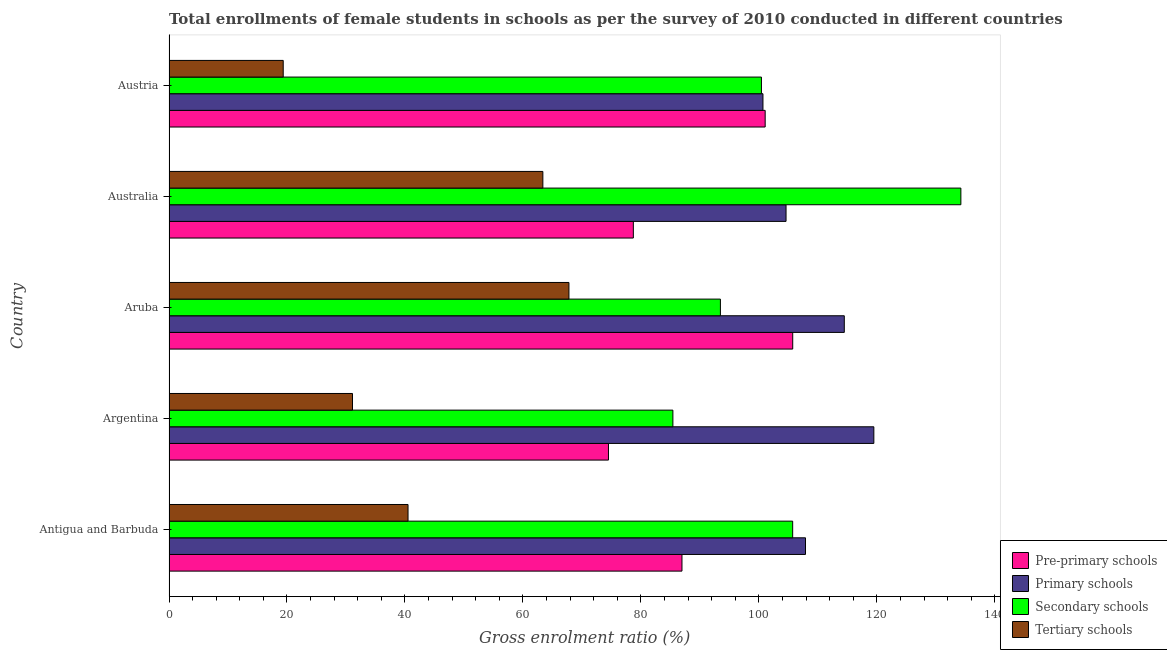How many different coloured bars are there?
Provide a succinct answer. 4. Are the number of bars per tick equal to the number of legend labels?
Your answer should be very brief. Yes. How many bars are there on the 2nd tick from the bottom?
Offer a very short reply. 4. What is the gross enrolment ratio(female) in primary schools in Aruba?
Your answer should be very brief. 114.48. Across all countries, what is the maximum gross enrolment ratio(female) in secondary schools?
Give a very brief answer. 134.24. Across all countries, what is the minimum gross enrolment ratio(female) in pre-primary schools?
Your answer should be compact. 74.5. In which country was the gross enrolment ratio(female) in pre-primary schools maximum?
Provide a short and direct response. Aruba. In which country was the gross enrolment ratio(female) in secondary schools minimum?
Provide a succinct answer. Argentina. What is the total gross enrolment ratio(female) in pre-primary schools in the graph?
Your answer should be very brief. 446.97. What is the difference between the gross enrolment ratio(female) in primary schools in Antigua and Barbuda and that in Aruba?
Offer a very short reply. -6.58. What is the difference between the gross enrolment ratio(female) in tertiary schools in Australia and the gross enrolment ratio(female) in primary schools in Aruba?
Provide a succinct answer. -51.1. What is the average gross enrolment ratio(female) in pre-primary schools per country?
Provide a succinct answer. 89.39. What is the difference between the gross enrolment ratio(female) in pre-primary schools and gross enrolment ratio(female) in tertiary schools in Antigua and Barbuda?
Your answer should be compact. 46.44. In how many countries, is the gross enrolment ratio(female) in secondary schools greater than 44 %?
Ensure brevity in your answer.  5. What is the ratio of the gross enrolment ratio(female) in pre-primary schools in Australia to that in Austria?
Give a very brief answer. 0.78. Is the gross enrolment ratio(female) in secondary schools in Argentina less than that in Austria?
Offer a terse response. Yes. Is the difference between the gross enrolment ratio(female) in secondary schools in Argentina and Australia greater than the difference between the gross enrolment ratio(female) in tertiary schools in Argentina and Australia?
Ensure brevity in your answer.  No. What is the difference between the highest and the second highest gross enrolment ratio(female) in pre-primary schools?
Your response must be concise. 4.67. What is the difference between the highest and the lowest gross enrolment ratio(female) in pre-primary schools?
Your answer should be compact. 31.23. Is it the case that in every country, the sum of the gross enrolment ratio(female) in primary schools and gross enrolment ratio(female) in secondary schools is greater than the sum of gross enrolment ratio(female) in pre-primary schools and gross enrolment ratio(female) in tertiary schools?
Provide a short and direct response. Yes. What does the 2nd bar from the top in Aruba represents?
Give a very brief answer. Secondary schools. What does the 1st bar from the bottom in Austria represents?
Ensure brevity in your answer.  Pre-primary schools. Is it the case that in every country, the sum of the gross enrolment ratio(female) in pre-primary schools and gross enrolment ratio(female) in primary schools is greater than the gross enrolment ratio(female) in secondary schools?
Your answer should be very brief. Yes. Are all the bars in the graph horizontal?
Give a very brief answer. Yes. What is the difference between two consecutive major ticks on the X-axis?
Give a very brief answer. 20. Are the values on the major ticks of X-axis written in scientific E-notation?
Make the answer very short. No. Does the graph contain any zero values?
Your answer should be very brief. No. Where does the legend appear in the graph?
Provide a short and direct response. Bottom right. What is the title of the graph?
Offer a very short reply. Total enrollments of female students in schools as per the survey of 2010 conducted in different countries. What is the label or title of the X-axis?
Keep it short and to the point. Gross enrolment ratio (%). What is the Gross enrolment ratio (%) of Pre-primary schools in Antigua and Barbuda?
Offer a very short reply. 86.96. What is the Gross enrolment ratio (%) in Primary schools in Antigua and Barbuda?
Offer a very short reply. 107.9. What is the Gross enrolment ratio (%) in Secondary schools in Antigua and Barbuda?
Provide a succinct answer. 105.73. What is the Gross enrolment ratio (%) in Tertiary schools in Antigua and Barbuda?
Ensure brevity in your answer.  40.52. What is the Gross enrolment ratio (%) in Pre-primary schools in Argentina?
Keep it short and to the point. 74.5. What is the Gross enrolment ratio (%) in Primary schools in Argentina?
Provide a succinct answer. 119.49. What is the Gross enrolment ratio (%) of Secondary schools in Argentina?
Your response must be concise. 85.42. What is the Gross enrolment ratio (%) of Tertiary schools in Argentina?
Your answer should be compact. 31.11. What is the Gross enrolment ratio (%) in Pre-primary schools in Aruba?
Your response must be concise. 105.73. What is the Gross enrolment ratio (%) of Primary schools in Aruba?
Ensure brevity in your answer.  114.48. What is the Gross enrolment ratio (%) of Secondary schools in Aruba?
Offer a terse response. 93.48. What is the Gross enrolment ratio (%) of Tertiary schools in Aruba?
Your answer should be compact. 67.8. What is the Gross enrolment ratio (%) in Pre-primary schools in Australia?
Offer a terse response. 78.72. What is the Gross enrolment ratio (%) of Primary schools in Australia?
Make the answer very short. 104.6. What is the Gross enrolment ratio (%) in Secondary schools in Australia?
Offer a very short reply. 134.24. What is the Gross enrolment ratio (%) in Tertiary schools in Australia?
Offer a terse response. 63.38. What is the Gross enrolment ratio (%) of Pre-primary schools in Austria?
Provide a succinct answer. 101.06. What is the Gross enrolment ratio (%) in Primary schools in Austria?
Keep it short and to the point. 100.69. What is the Gross enrolment ratio (%) of Secondary schools in Austria?
Make the answer very short. 100.43. What is the Gross enrolment ratio (%) of Tertiary schools in Austria?
Keep it short and to the point. 19.36. Across all countries, what is the maximum Gross enrolment ratio (%) in Pre-primary schools?
Offer a very short reply. 105.73. Across all countries, what is the maximum Gross enrolment ratio (%) of Primary schools?
Keep it short and to the point. 119.49. Across all countries, what is the maximum Gross enrolment ratio (%) in Secondary schools?
Provide a succinct answer. 134.24. Across all countries, what is the maximum Gross enrolment ratio (%) in Tertiary schools?
Your response must be concise. 67.8. Across all countries, what is the minimum Gross enrolment ratio (%) in Pre-primary schools?
Give a very brief answer. 74.5. Across all countries, what is the minimum Gross enrolment ratio (%) of Primary schools?
Your answer should be very brief. 100.69. Across all countries, what is the minimum Gross enrolment ratio (%) of Secondary schools?
Give a very brief answer. 85.42. Across all countries, what is the minimum Gross enrolment ratio (%) of Tertiary schools?
Provide a succinct answer. 19.36. What is the total Gross enrolment ratio (%) in Pre-primary schools in the graph?
Your response must be concise. 446.97. What is the total Gross enrolment ratio (%) in Primary schools in the graph?
Your answer should be very brief. 547.15. What is the total Gross enrolment ratio (%) in Secondary schools in the graph?
Offer a very short reply. 519.29. What is the total Gross enrolment ratio (%) in Tertiary schools in the graph?
Make the answer very short. 222.17. What is the difference between the Gross enrolment ratio (%) in Pre-primary schools in Antigua and Barbuda and that in Argentina?
Your answer should be very brief. 12.46. What is the difference between the Gross enrolment ratio (%) in Primary schools in Antigua and Barbuda and that in Argentina?
Ensure brevity in your answer.  -11.59. What is the difference between the Gross enrolment ratio (%) in Secondary schools in Antigua and Barbuda and that in Argentina?
Your answer should be compact. 20.31. What is the difference between the Gross enrolment ratio (%) of Tertiary schools in Antigua and Barbuda and that in Argentina?
Offer a very short reply. 9.41. What is the difference between the Gross enrolment ratio (%) in Pre-primary schools in Antigua and Barbuda and that in Aruba?
Your answer should be compact. -18.77. What is the difference between the Gross enrolment ratio (%) in Primary schools in Antigua and Barbuda and that in Aruba?
Make the answer very short. -6.58. What is the difference between the Gross enrolment ratio (%) of Secondary schools in Antigua and Barbuda and that in Aruba?
Give a very brief answer. 12.25. What is the difference between the Gross enrolment ratio (%) of Tertiary schools in Antigua and Barbuda and that in Aruba?
Offer a terse response. -27.28. What is the difference between the Gross enrolment ratio (%) in Pre-primary schools in Antigua and Barbuda and that in Australia?
Your answer should be very brief. 8.24. What is the difference between the Gross enrolment ratio (%) of Primary schools in Antigua and Barbuda and that in Australia?
Make the answer very short. 3.3. What is the difference between the Gross enrolment ratio (%) in Secondary schools in Antigua and Barbuda and that in Australia?
Your response must be concise. -28.52. What is the difference between the Gross enrolment ratio (%) of Tertiary schools in Antigua and Barbuda and that in Australia?
Provide a succinct answer. -22.86. What is the difference between the Gross enrolment ratio (%) in Pre-primary schools in Antigua and Barbuda and that in Austria?
Make the answer very short. -14.1. What is the difference between the Gross enrolment ratio (%) in Primary schools in Antigua and Barbuda and that in Austria?
Ensure brevity in your answer.  7.21. What is the difference between the Gross enrolment ratio (%) of Secondary schools in Antigua and Barbuda and that in Austria?
Your answer should be compact. 5.29. What is the difference between the Gross enrolment ratio (%) in Tertiary schools in Antigua and Barbuda and that in Austria?
Ensure brevity in your answer.  21.16. What is the difference between the Gross enrolment ratio (%) in Pre-primary schools in Argentina and that in Aruba?
Give a very brief answer. -31.23. What is the difference between the Gross enrolment ratio (%) in Primary schools in Argentina and that in Aruba?
Provide a short and direct response. 5.01. What is the difference between the Gross enrolment ratio (%) of Secondary schools in Argentina and that in Aruba?
Your answer should be compact. -8.06. What is the difference between the Gross enrolment ratio (%) in Tertiary schools in Argentina and that in Aruba?
Offer a terse response. -36.69. What is the difference between the Gross enrolment ratio (%) of Pre-primary schools in Argentina and that in Australia?
Your response must be concise. -4.22. What is the difference between the Gross enrolment ratio (%) in Primary schools in Argentina and that in Australia?
Make the answer very short. 14.88. What is the difference between the Gross enrolment ratio (%) in Secondary schools in Argentina and that in Australia?
Provide a short and direct response. -48.82. What is the difference between the Gross enrolment ratio (%) in Tertiary schools in Argentina and that in Australia?
Your response must be concise. -32.27. What is the difference between the Gross enrolment ratio (%) of Pre-primary schools in Argentina and that in Austria?
Provide a succinct answer. -26.56. What is the difference between the Gross enrolment ratio (%) of Primary schools in Argentina and that in Austria?
Offer a very short reply. 18.8. What is the difference between the Gross enrolment ratio (%) of Secondary schools in Argentina and that in Austria?
Offer a terse response. -15.01. What is the difference between the Gross enrolment ratio (%) in Tertiary schools in Argentina and that in Austria?
Offer a terse response. 11.75. What is the difference between the Gross enrolment ratio (%) of Pre-primary schools in Aruba and that in Australia?
Offer a terse response. 27.02. What is the difference between the Gross enrolment ratio (%) of Primary schools in Aruba and that in Australia?
Provide a short and direct response. 9.88. What is the difference between the Gross enrolment ratio (%) in Secondary schools in Aruba and that in Australia?
Give a very brief answer. -40.76. What is the difference between the Gross enrolment ratio (%) of Tertiary schools in Aruba and that in Australia?
Offer a terse response. 4.42. What is the difference between the Gross enrolment ratio (%) in Pre-primary schools in Aruba and that in Austria?
Ensure brevity in your answer.  4.67. What is the difference between the Gross enrolment ratio (%) of Primary schools in Aruba and that in Austria?
Offer a terse response. 13.79. What is the difference between the Gross enrolment ratio (%) in Secondary schools in Aruba and that in Austria?
Provide a short and direct response. -6.96. What is the difference between the Gross enrolment ratio (%) in Tertiary schools in Aruba and that in Austria?
Give a very brief answer. 48.43. What is the difference between the Gross enrolment ratio (%) of Pre-primary schools in Australia and that in Austria?
Make the answer very short. -22.35. What is the difference between the Gross enrolment ratio (%) in Primary schools in Australia and that in Austria?
Your answer should be very brief. 3.91. What is the difference between the Gross enrolment ratio (%) of Secondary schools in Australia and that in Austria?
Offer a very short reply. 33.81. What is the difference between the Gross enrolment ratio (%) in Tertiary schools in Australia and that in Austria?
Your answer should be compact. 44.02. What is the difference between the Gross enrolment ratio (%) in Pre-primary schools in Antigua and Barbuda and the Gross enrolment ratio (%) in Primary schools in Argentina?
Your answer should be compact. -32.53. What is the difference between the Gross enrolment ratio (%) in Pre-primary schools in Antigua and Barbuda and the Gross enrolment ratio (%) in Secondary schools in Argentina?
Give a very brief answer. 1.54. What is the difference between the Gross enrolment ratio (%) in Pre-primary schools in Antigua and Barbuda and the Gross enrolment ratio (%) in Tertiary schools in Argentina?
Make the answer very short. 55.85. What is the difference between the Gross enrolment ratio (%) of Primary schools in Antigua and Barbuda and the Gross enrolment ratio (%) of Secondary schools in Argentina?
Your response must be concise. 22.48. What is the difference between the Gross enrolment ratio (%) in Primary schools in Antigua and Barbuda and the Gross enrolment ratio (%) in Tertiary schools in Argentina?
Keep it short and to the point. 76.79. What is the difference between the Gross enrolment ratio (%) in Secondary schools in Antigua and Barbuda and the Gross enrolment ratio (%) in Tertiary schools in Argentina?
Your answer should be very brief. 74.62. What is the difference between the Gross enrolment ratio (%) of Pre-primary schools in Antigua and Barbuda and the Gross enrolment ratio (%) of Primary schools in Aruba?
Keep it short and to the point. -27.52. What is the difference between the Gross enrolment ratio (%) in Pre-primary schools in Antigua and Barbuda and the Gross enrolment ratio (%) in Secondary schools in Aruba?
Offer a very short reply. -6.52. What is the difference between the Gross enrolment ratio (%) of Pre-primary schools in Antigua and Barbuda and the Gross enrolment ratio (%) of Tertiary schools in Aruba?
Provide a short and direct response. 19.16. What is the difference between the Gross enrolment ratio (%) of Primary schools in Antigua and Barbuda and the Gross enrolment ratio (%) of Secondary schools in Aruba?
Your answer should be compact. 14.42. What is the difference between the Gross enrolment ratio (%) of Primary schools in Antigua and Barbuda and the Gross enrolment ratio (%) of Tertiary schools in Aruba?
Provide a short and direct response. 40.1. What is the difference between the Gross enrolment ratio (%) in Secondary schools in Antigua and Barbuda and the Gross enrolment ratio (%) in Tertiary schools in Aruba?
Ensure brevity in your answer.  37.93. What is the difference between the Gross enrolment ratio (%) of Pre-primary schools in Antigua and Barbuda and the Gross enrolment ratio (%) of Primary schools in Australia?
Make the answer very short. -17.64. What is the difference between the Gross enrolment ratio (%) in Pre-primary schools in Antigua and Barbuda and the Gross enrolment ratio (%) in Secondary schools in Australia?
Give a very brief answer. -47.28. What is the difference between the Gross enrolment ratio (%) in Pre-primary schools in Antigua and Barbuda and the Gross enrolment ratio (%) in Tertiary schools in Australia?
Provide a succinct answer. 23.58. What is the difference between the Gross enrolment ratio (%) in Primary schools in Antigua and Barbuda and the Gross enrolment ratio (%) in Secondary schools in Australia?
Make the answer very short. -26.34. What is the difference between the Gross enrolment ratio (%) in Primary schools in Antigua and Barbuda and the Gross enrolment ratio (%) in Tertiary schools in Australia?
Make the answer very short. 44.52. What is the difference between the Gross enrolment ratio (%) of Secondary schools in Antigua and Barbuda and the Gross enrolment ratio (%) of Tertiary schools in Australia?
Make the answer very short. 42.35. What is the difference between the Gross enrolment ratio (%) in Pre-primary schools in Antigua and Barbuda and the Gross enrolment ratio (%) in Primary schools in Austria?
Your answer should be compact. -13.73. What is the difference between the Gross enrolment ratio (%) in Pre-primary schools in Antigua and Barbuda and the Gross enrolment ratio (%) in Secondary schools in Austria?
Make the answer very short. -13.47. What is the difference between the Gross enrolment ratio (%) in Pre-primary schools in Antigua and Barbuda and the Gross enrolment ratio (%) in Tertiary schools in Austria?
Offer a very short reply. 67.6. What is the difference between the Gross enrolment ratio (%) of Primary schools in Antigua and Barbuda and the Gross enrolment ratio (%) of Secondary schools in Austria?
Give a very brief answer. 7.47. What is the difference between the Gross enrolment ratio (%) in Primary schools in Antigua and Barbuda and the Gross enrolment ratio (%) in Tertiary schools in Austria?
Your answer should be very brief. 88.54. What is the difference between the Gross enrolment ratio (%) in Secondary schools in Antigua and Barbuda and the Gross enrolment ratio (%) in Tertiary schools in Austria?
Ensure brevity in your answer.  86.36. What is the difference between the Gross enrolment ratio (%) in Pre-primary schools in Argentina and the Gross enrolment ratio (%) in Primary schools in Aruba?
Provide a succinct answer. -39.98. What is the difference between the Gross enrolment ratio (%) in Pre-primary schools in Argentina and the Gross enrolment ratio (%) in Secondary schools in Aruba?
Offer a terse response. -18.98. What is the difference between the Gross enrolment ratio (%) of Pre-primary schools in Argentina and the Gross enrolment ratio (%) of Tertiary schools in Aruba?
Provide a short and direct response. 6.7. What is the difference between the Gross enrolment ratio (%) in Primary schools in Argentina and the Gross enrolment ratio (%) in Secondary schools in Aruba?
Provide a short and direct response. 26.01. What is the difference between the Gross enrolment ratio (%) of Primary schools in Argentina and the Gross enrolment ratio (%) of Tertiary schools in Aruba?
Your answer should be compact. 51.69. What is the difference between the Gross enrolment ratio (%) of Secondary schools in Argentina and the Gross enrolment ratio (%) of Tertiary schools in Aruba?
Your answer should be very brief. 17.62. What is the difference between the Gross enrolment ratio (%) of Pre-primary schools in Argentina and the Gross enrolment ratio (%) of Primary schools in Australia?
Your response must be concise. -30.1. What is the difference between the Gross enrolment ratio (%) in Pre-primary schools in Argentina and the Gross enrolment ratio (%) in Secondary schools in Australia?
Your response must be concise. -59.74. What is the difference between the Gross enrolment ratio (%) in Pre-primary schools in Argentina and the Gross enrolment ratio (%) in Tertiary schools in Australia?
Your answer should be very brief. 11.12. What is the difference between the Gross enrolment ratio (%) of Primary schools in Argentina and the Gross enrolment ratio (%) of Secondary schools in Australia?
Make the answer very short. -14.76. What is the difference between the Gross enrolment ratio (%) in Primary schools in Argentina and the Gross enrolment ratio (%) in Tertiary schools in Australia?
Your answer should be very brief. 56.11. What is the difference between the Gross enrolment ratio (%) of Secondary schools in Argentina and the Gross enrolment ratio (%) of Tertiary schools in Australia?
Offer a very short reply. 22.04. What is the difference between the Gross enrolment ratio (%) of Pre-primary schools in Argentina and the Gross enrolment ratio (%) of Primary schools in Austria?
Provide a succinct answer. -26.19. What is the difference between the Gross enrolment ratio (%) in Pre-primary schools in Argentina and the Gross enrolment ratio (%) in Secondary schools in Austria?
Keep it short and to the point. -25.93. What is the difference between the Gross enrolment ratio (%) of Pre-primary schools in Argentina and the Gross enrolment ratio (%) of Tertiary schools in Austria?
Your response must be concise. 55.14. What is the difference between the Gross enrolment ratio (%) in Primary schools in Argentina and the Gross enrolment ratio (%) in Secondary schools in Austria?
Your answer should be compact. 19.05. What is the difference between the Gross enrolment ratio (%) in Primary schools in Argentina and the Gross enrolment ratio (%) in Tertiary schools in Austria?
Ensure brevity in your answer.  100.12. What is the difference between the Gross enrolment ratio (%) of Secondary schools in Argentina and the Gross enrolment ratio (%) of Tertiary schools in Austria?
Ensure brevity in your answer.  66.06. What is the difference between the Gross enrolment ratio (%) of Pre-primary schools in Aruba and the Gross enrolment ratio (%) of Primary schools in Australia?
Give a very brief answer. 1.13. What is the difference between the Gross enrolment ratio (%) of Pre-primary schools in Aruba and the Gross enrolment ratio (%) of Secondary schools in Australia?
Your response must be concise. -28.51. What is the difference between the Gross enrolment ratio (%) of Pre-primary schools in Aruba and the Gross enrolment ratio (%) of Tertiary schools in Australia?
Your answer should be compact. 42.36. What is the difference between the Gross enrolment ratio (%) in Primary schools in Aruba and the Gross enrolment ratio (%) in Secondary schools in Australia?
Offer a very short reply. -19.76. What is the difference between the Gross enrolment ratio (%) of Primary schools in Aruba and the Gross enrolment ratio (%) of Tertiary schools in Australia?
Offer a terse response. 51.1. What is the difference between the Gross enrolment ratio (%) of Secondary schools in Aruba and the Gross enrolment ratio (%) of Tertiary schools in Australia?
Give a very brief answer. 30.1. What is the difference between the Gross enrolment ratio (%) in Pre-primary schools in Aruba and the Gross enrolment ratio (%) in Primary schools in Austria?
Provide a short and direct response. 5.05. What is the difference between the Gross enrolment ratio (%) in Pre-primary schools in Aruba and the Gross enrolment ratio (%) in Secondary schools in Austria?
Your response must be concise. 5.3. What is the difference between the Gross enrolment ratio (%) in Pre-primary schools in Aruba and the Gross enrolment ratio (%) in Tertiary schools in Austria?
Keep it short and to the point. 86.37. What is the difference between the Gross enrolment ratio (%) of Primary schools in Aruba and the Gross enrolment ratio (%) of Secondary schools in Austria?
Your answer should be compact. 14.05. What is the difference between the Gross enrolment ratio (%) of Primary schools in Aruba and the Gross enrolment ratio (%) of Tertiary schools in Austria?
Ensure brevity in your answer.  95.11. What is the difference between the Gross enrolment ratio (%) in Secondary schools in Aruba and the Gross enrolment ratio (%) in Tertiary schools in Austria?
Your answer should be very brief. 74.11. What is the difference between the Gross enrolment ratio (%) in Pre-primary schools in Australia and the Gross enrolment ratio (%) in Primary schools in Austria?
Ensure brevity in your answer.  -21.97. What is the difference between the Gross enrolment ratio (%) of Pre-primary schools in Australia and the Gross enrolment ratio (%) of Secondary schools in Austria?
Keep it short and to the point. -21.72. What is the difference between the Gross enrolment ratio (%) of Pre-primary schools in Australia and the Gross enrolment ratio (%) of Tertiary schools in Austria?
Ensure brevity in your answer.  59.35. What is the difference between the Gross enrolment ratio (%) of Primary schools in Australia and the Gross enrolment ratio (%) of Secondary schools in Austria?
Give a very brief answer. 4.17. What is the difference between the Gross enrolment ratio (%) of Primary schools in Australia and the Gross enrolment ratio (%) of Tertiary schools in Austria?
Give a very brief answer. 85.24. What is the difference between the Gross enrolment ratio (%) in Secondary schools in Australia and the Gross enrolment ratio (%) in Tertiary schools in Austria?
Provide a short and direct response. 114.88. What is the average Gross enrolment ratio (%) in Pre-primary schools per country?
Keep it short and to the point. 89.39. What is the average Gross enrolment ratio (%) of Primary schools per country?
Keep it short and to the point. 109.43. What is the average Gross enrolment ratio (%) in Secondary schools per country?
Offer a very short reply. 103.86. What is the average Gross enrolment ratio (%) of Tertiary schools per country?
Provide a succinct answer. 44.43. What is the difference between the Gross enrolment ratio (%) of Pre-primary schools and Gross enrolment ratio (%) of Primary schools in Antigua and Barbuda?
Offer a very short reply. -20.94. What is the difference between the Gross enrolment ratio (%) in Pre-primary schools and Gross enrolment ratio (%) in Secondary schools in Antigua and Barbuda?
Your response must be concise. -18.77. What is the difference between the Gross enrolment ratio (%) of Pre-primary schools and Gross enrolment ratio (%) of Tertiary schools in Antigua and Barbuda?
Your answer should be compact. 46.44. What is the difference between the Gross enrolment ratio (%) in Primary schools and Gross enrolment ratio (%) in Secondary schools in Antigua and Barbuda?
Provide a succinct answer. 2.18. What is the difference between the Gross enrolment ratio (%) in Primary schools and Gross enrolment ratio (%) in Tertiary schools in Antigua and Barbuda?
Make the answer very short. 67.38. What is the difference between the Gross enrolment ratio (%) of Secondary schools and Gross enrolment ratio (%) of Tertiary schools in Antigua and Barbuda?
Make the answer very short. 65.2. What is the difference between the Gross enrolment ratio (%) in Pre-primary schools and Gross enrolment ratio (%) in Primary schools in Argentina?
Your answer should be compact. -44.99. What is the difference between the Gross enrolment ratio (%) in Pre-primary schools and Gross enrolment ratio (%) in Secondary schools in Argentina?
Make the answer very short. -10.92. What is the difference between the Gross enrolment ratio (%) in Pre-primary schools and Gross enrolment ratio (%) in Tertiary schools in Argentina?
Offer a terse response. 43.39. What is the difference between the Gross enrolment ratio (%) in Primary schools and Gross enrolment ratio (%) in Secondary schools in Argentina?
Your response must be concise. 34.07. What is the difference between the Gross enrolment ratio (%) of Primary schools and Gross enrolment ratio (%) of Tertiary schools in Argentina?
Ensure brevity in your answer.  88.38. What is the difference between the Gross enrolment ratio (%) in Secondary schools and Gross enrolment ratio (%) in Tertiary schools in Argentina?
Offer a terse response. 54.31. What is the difference between the Gross enrolment ratio (%) in Pre-primary schools and Gross enrolment ratio (%) in Primary schools in Aruba?
Keep it short and to the point. -8.74. What is the difference between the Gross enrolment ratio (%) in Pre-primary schools and Gross enrolment ratio (%) in Secondary schools in Aruba?
Your response must be concise. 12.26. What is the difference between the Gross enrolment ratio (%) of Pre-primary schools and Gross enrolment ratio (%) of Tertiary schools in Aruba?
Provide a succinct answer. 37.94. What is the difference between the Gross enrolment ratio (%) of Primary schools and Gross enrolment ratio (%) of Secondary schools in Aruba?
Give a very brief answer. 21. What is the difference between the Gross enrolment ratio (%) in Primary schools and Gross enrolment ratio (%) in Tertiary schools in Aruba?
Give a very brief answer. 46.68. What is the difference between the Gross enrolment ratio (%) of Secondary schools and Gross enrolment ratio (%) of Tertiary schools in Aruba?
Give a very brief answer. 25.68. What is the difference between the Gross enrolment ratio (%) in Pre-primary schools and Gross enrolment ratio (%) in Primary schools in Australia?
Provide a succinct answer. -25.89. What is the difference between the Gross enrolment ratio (%) of Pre-primary schools and Gross enrolment ratio (%) of Secondary schools in Australia?
Make the answer very short. -55.53. What is the difference between the Gross enrolment ratio (%) in Pre-primary schools and Gross enrolment ratio (%) in Tertiary schools in Australia?
Your answer should be compact. 15.34. What is the difference between the Gross enrolment ratio (%) of Primary schools and Gross enrolment ratio (%) of Secondary schools in Australia?
Provide a short and direct response. -29.64. What is the difference between the Gross enrolment ratio (%) of Primary schools and Gross enrolment ratio (%) of Tertiary schools in Australia?
Make the answer very short. 41.22. What is the difference between the Gross enrolment ratio (%) in Secondary schools and Gross enrolment ratio (%) in Tertiary schools in Australia?
Ensure brevity in your answer.  70.86. What is the difference between the Gross enrolment ratio (%) in Pre-primary schools and Gross enrolment ratio (%) in Primary schools in Austria?
Keep it short and to the point. 0.38. What is the difference between the Gross enrolment ratio (%) in Pre-primary schools and Gross enrolment ratio (%) in Secondary schools in Austria?
Your answer should be very brief. 0.63. What is the difference between the Gross enrolment ratio (%) in Pre-primary schools and Gross enrolment ratio (%) in Tertiary schools in Austria?
Your response must be concise. 81.7. What is the difference between the Gross enrolment ratio (%) of Primary schools and Gross enrolment ratio (%) of Secondary schools in Austria?
Ensure brevity in your answer.  0.26. What is the difference between the Gross enrolment ratio (%) in Primary schools and Gross enrolment ratio (%) in Tertiary schools in Austria?
Your response must be concise. 81.33. What is the difference between the Gross enrolment ratio (%) in Secondary schools and Gross enrolment ratio (%) in Tertiary schools in Austria?
Your answer should be compact. 81.07. What is the ratio of the Gross enrolment ratio (%) in Pre-primary schools in Antigua and Barbuda to that in Argentina?
Your answer should be compact. 1.17. What is the ratio of the Gross enrolment ratio (%) of Primary schools in Antigua and Barbuda to that in Argentina?
Keep it short and to the point. 0.9. What is the ratio of the Gross enrolment ratio (%) of Secondary schools in Antigua and Barbuda to that in Argentina?
Your answer should be compact. 1.24. What is the ratio of the Gross enrolment ratio (%) in Tertiary schools in Antigua and Barbuda to that in Argentina?
Provide a succinct answer. 1.3. What is the ratio of the Gross enrolment ratio (%) of Pre-primary schools in Antigua and Barbuda to that in Aruba?
Offer a very short reply. 0.82. What is the ratio of the Gross enrolment ratio (%) of Primary schools in Antigua and Barbuda to that in Aruba?
Offer a very short reply. 0.94. What is the ratio of the Gross enrolment ratio (%) of Secondary schools in Antigua and Barbuda to that in Aruba?
Offer a terse response. 1.13. What is the ratio of the Gross enrolment ratio (%) of Tertiary schools in Antigua and Barbuda to that in Aruba?
Keep it short and to the point. 0.6. What is the ratio of the Gross enrolment ratio (%) of Pre-primary schools in Antigua and Barbuda to that in Australia?
Your answer should be very brief. 1.1. What is the ratio of the Gross enrolment ratio (%) of Primary schools in Antigua and Barbuda to that in Australia?
Ensure brevity in your answer.  1.03. What is the ratio of the Gross enrolment ratio (%) of Secondary schools in Antigua and Barbuda to that in Australia?
Your response must be concise. 0.79. What is the ratio of the Gross enrolment ratio (%) in Tertiary schools in Antigua and Barbuda to that in Australia?
Offer a terse response. 0.64. What is the ratio of the Gross enrolment ratio (%) of Pre-primary schools in Antigua and Barbuda to that in Austria?
Provide a short and direct response. 0.86. What is the ratio of the Gross enrolment ratio (%) in Primary schools in Antigua and Barbuda to that in Austria?
Ensure brevity in your answer.  1.07. What is the ratio of the Gross enrolment ratio (%) of Secondary schools in Antigua and Barbuda to that in Austria?
Offer a terse response. 1.05. What is the ratio of the Gross enrolment ratio (%) in Tertiary schools in Antigua and Barbuda to that in Austria?
Keep it short and to the point. 2.09. What is the ratio of the Gross enrolment ratio (%) of Pre-primary schools in Argentina to that in Aruba?
Offer a terse response. 0.7. What is the ratio of the Gross enrolment ratio (%) in Primary schools in Argentina to that in Aruba?
Your response must be concise. 1.04. What is the ratio of the Gross enrolment ratio (%) of Secondary schools in Argentina to that in Aruba?
Ensure brevity in your answer.  0.91. What is the ratio of the Gross enrolment ratio (%) of Tertiary schools in Argentina to that in Aruba?
Your response must be concise. 0.46. What is the ratio of the Gross enrolment ratio (%) in Pre-primary schools in Argentina to that in Australia?
Offer a terse response. 0.95. What is the ratio of the Gross enrolment ratio (%) of Primary schools in Argentina to that in Australia?
Make the answer very short. 1.14. What is the ratio of the Gross enrolment ratio (%) in Secondary schools in Argentina to that in Australia?
Your response must be concise. 0.64. What is the ratio of the Gross enrolment ratio (%) in Tertiary schools in Argentina to that in Australia?
Your answer should be very brief. 0.49. What is the ratio of the Gross enrolment ratio (%) of Pre-primary schools in Argentina to that in Austria?
Give a very brief answer. 0.74. What is the ratio of the Gross enrolment ratio (%) in Primary schools in Argentina to that in Austria?
Make the answer very short. 1.19. What is the ratio of the Gross enrolment ratio (%) of Secondary schools in Argentina to that in Austria?
Keep it short and to the point. 0.85. What is the ratio of the Gross enrolment ratio (%) in Tertiary schools in Argentina to that in Austria?
Provide a short and direct response. 1.61. What is the ratio of the Gross enrolment ratio (%) of Pre-primary schools in Aruba to that in Australia?
Your answer should be compact. 1.34. What is the ratio of the Gross enrolment ratio (%) in Primary schools in Aruba to that in Australia?
Provide a short and direct response. 1.09. What is the ratio of the Gross enrolment ratio (%) in Secondary schools in Aruba to that in Australia?
Provide a short and direct response. 0.7. What is the ratio of the Gross enrolment ratio (%) in Tertiary schools in Aruba to that in Australia?
Make the answer very short. 1.07. What is the ratio of the Gross enrolment ratio (%) in Pre-primary schools in Aruba to that in Austria?
Offer a terse response. 1.05. What is the ratio of the Gross enrolment ratio (%) of Primary schools in Aruba to that in Austria?
Ensure brevity in your answer.  1.14. What is the ratio of the Gross enrolment ratio (%) of Secondary schools in Aruba to that in Austria?
Your answer should be compact. 0.93. What is the ratio of the Gross enrolment ratio (%) of Tertiary schools in Aruba to that in Austria?
Ensure brevity in your answer.  3.5. What is the ratio of the Gross enrolment ratio (%) in Pre-primary schools in Australia to that in Austria?
Your answer should be very brief. 0.78. What is the ratio of the Gross enrolment ratio (%) of Primary schools in Australia to that in Austria?
Offer a very short reply. 1.04. What is the ratio of the Gross enrolment ratio (%) of Secondary schools in Australia to that in Austria?
Keep it short and to the point. 1.34. What is the ratio of the Gross enrolment ratio (%) of Tertiary schools in Australia to that in Austria?
Ensure brevity in your answer.  3.27. What is the difference between the highest and the second highest Gross enrolment ratio (%) of Pre-primary schools?
Your answer should be very brief. 4.67. What is the difference between the highest and the second highest Gross enrolment ratio (%) in Primary schools?
Provide a short and direct response. 5.01. What is the difference between the highest and the second highest Gross enrolment ratio (%) of Secondary schools?
Your answer should be compact. 28.52. What is the difference between the highest and the second highest Gross enrolment ratio (%) in Tertiary schools?
Provide a succinct answer. 4.42. What is the difference between the highest and the lowest Gross enrolment ratio (%) in Pre-primary schools?
Provide a short and direct response. 31.23. What is the difference between the highest and the lowest Gross enrolment ratio (%) in Primary schools?
Your answer should be very brief. 18.8. What is the difference between the highest and the lowest Gross enrolment ratio (%) in Secondary schools?
Your response must be concise. 48.82. What is the difference between the highest and the lowest Gross enrolment ratio (%) in Tertiary schools?
Offer a very short reply. 48.43. 